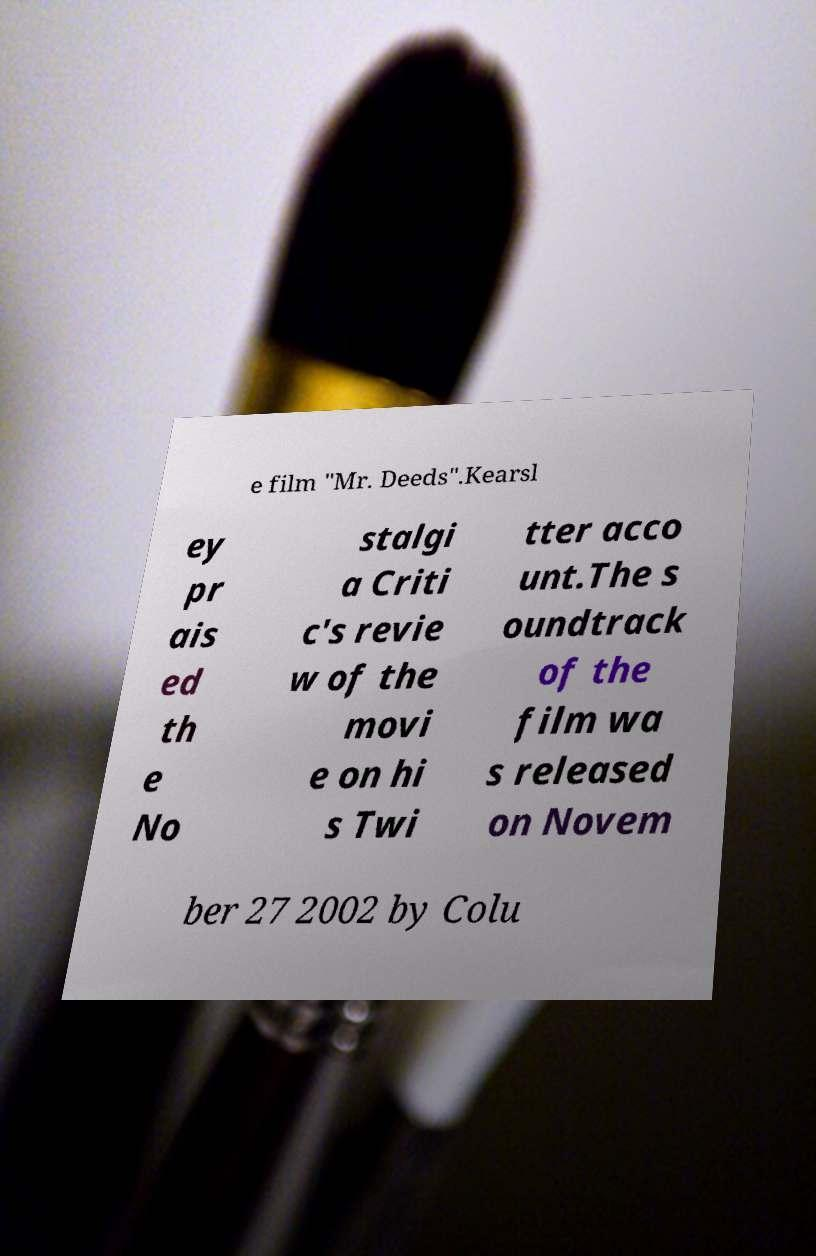There's text embedded in this image that I need extracted. Can you transcribe it verbatim? e film "Mr. Deeds".Kearsl ey pr ais ed th e No stalgi a Criti c's revie w of the movi e on hi s Twi tter acco unt.The s oundtrack of the film wa s released on Novem ber 27 2002 by Colu 